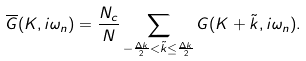Convert formula to latex. <formula><loc_0><loc_0><loc_500><loc_500>\overline { G } ( K , i \omega _ { n } ) = \frac { N _ { c } } { N } \sum _ { - \frac { \Delta k } { 2 } < \tilde { k } \leq \frac { \Delta k } { 2 } } G ( K + \tilde { k } , i \omega _ { n } ) .</formula> 